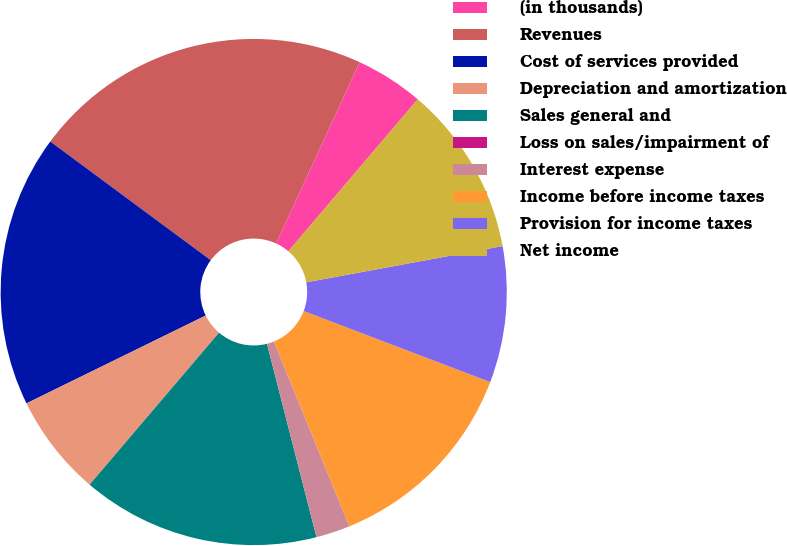Convert chart to OTSL. <chart><loc_0><loc_0><loc_500><loc_500><pie_chart><fcel>(in thousands)<fcel>Revenues<fcel>Cost of services provided<fcel>Depreciation and amortization<fcel>Sales general and<fcel>Loss on sales/impairment of<fcel>Interest expense<fcel>Income before income taxes<fcel>Provision for income taxes<fcel>Net income<nl><fcel>4.35%<fcel>21.74%<fcel>17.39%<fcel>6.52%<fcel>15.22%<fcel>0.0%<fcel>2.18%<fcel>13.04%<fcel>8.7%<fcel>10.87%<nl></chart> 